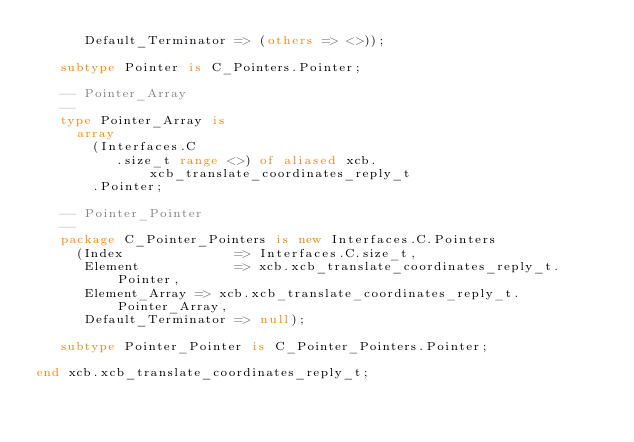Convert code to text. <code><loc_0><loc_0><loc_500><loc_500><_Ada_>      Default_Terminator => (others => <>));

   subtype Pointer is C_Pointers.Pointer;

   -- Pointer_Array
   --
   type Pointer_Array is
     array
       (Interfaces.C
          .size_t range <>) of aliased xcb.xcb_translate_coordinates_reply_t
       .Pointer;

   -- Pointer_Pointer
   --
   package C_Pointer_Pointers is new Interfaces.C.Pointers
     (Index              => Interfaces.C.size_t,
      Element            => xcb.xcb_translate_coordinates_reply_t.Pointer,
      Element_Array => xcb.xcb_translate_coordinates_reply_t.Pointer_Array,
      Default_Terminator => null);

   subtype Pointer_Pointer is C_Pointer_Pointers.Pointer;

end xcb.xcb_translate_coordinates_reply_t;
</code> 